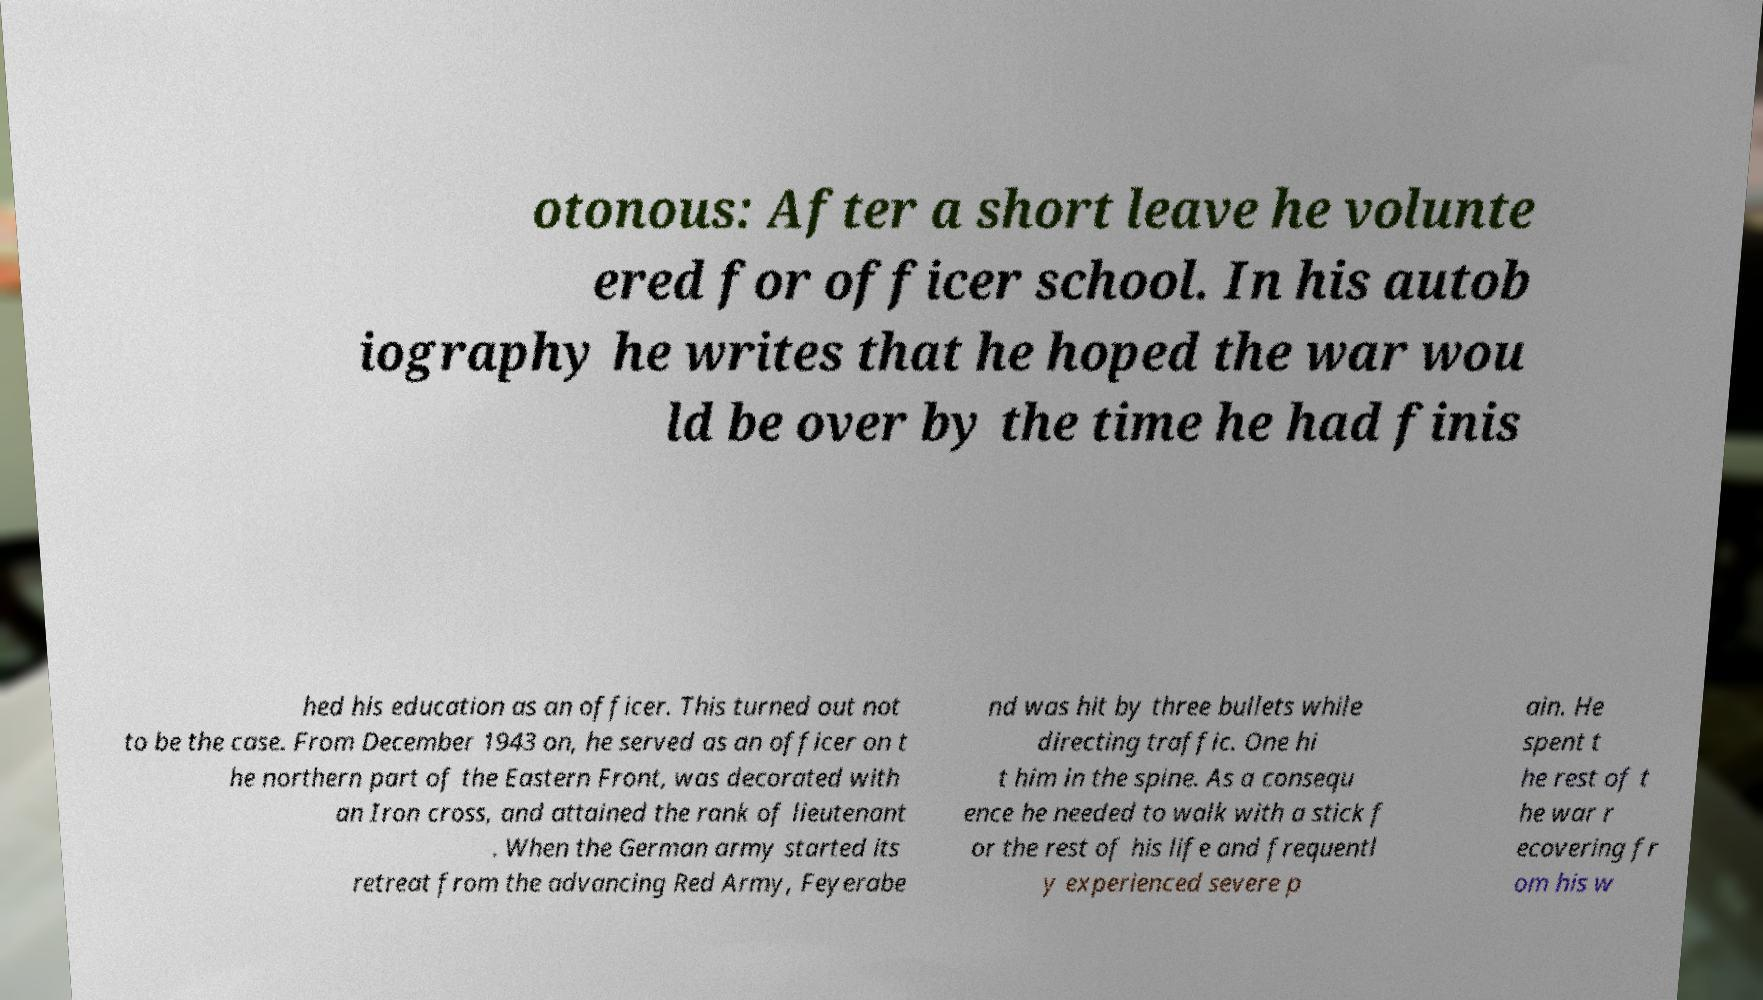Can you read and provide the text displayed in the image?This photo seems to have some interesting text. Can you extract and type it out for me? otonous: After a short leave he volunte ered for officer school. In his autob iography he writes that he hoped the war wou ld be over by the time he had finis hed his education as an officer. This turned out not to be the case. From December 1943 on, he served as an officer on t he northern part of the Eastern Front, was decorated with an Iron cross, and attained the rank of lieutenant . When the German army started its retreat from the advancing Red Army, Feyerabe nd was hit by three bullets while directing traffic. One hi t him in the spine. As a consequ ence he needed to walk with a stick f or the rest of his life and frequentl y experienced severe p ain. He spent t he rest of t he war r ecovering fr om his w 